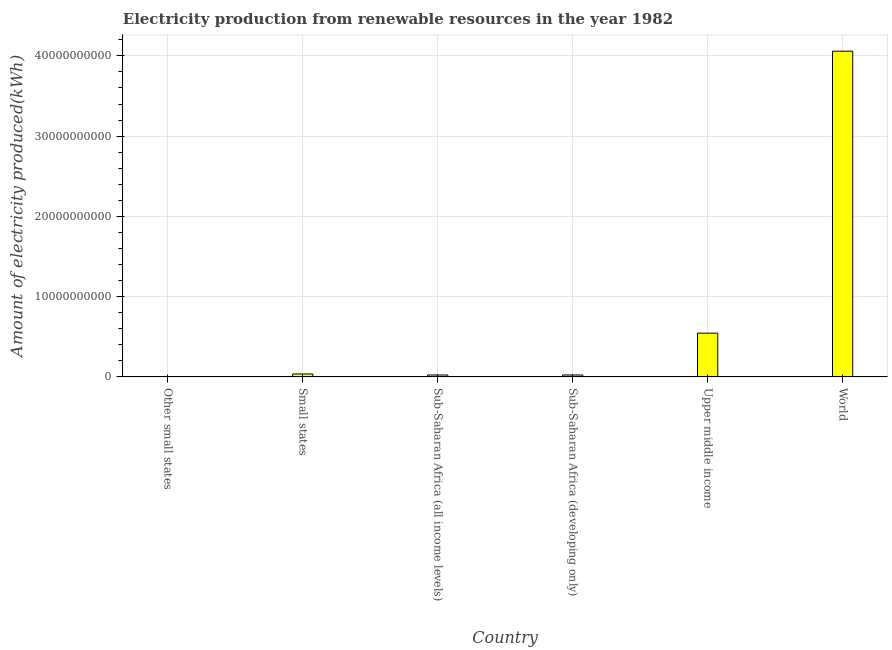Does the graph contain any zero values?
Provide a short and direct response. No. What is the title of the graph?
Offer a terse response. Electricity production from renewable resources in the year 1982. What is the label or title of the Y-axis?
Provide a short and direct response. Amount of electricity produced(kWh). What is the amount of electricity produced in Small states?
Offer a terse response. 3.60e+08. Across all countries, what is the maximum amount of electricity produced?
Provide a short and direct response. 4.06e+1. Across all countries, what is the minimum amount of electricity produced?
Offer a very short reply. 4.30e+07. In which country was the amount of electricity produced maximum?
Make the answer very short. World. In which country was the amount of electricity produced minimum?
Make the answer very short. Other small states. What is the sum of the amount of electricity produced?
Your answer should be compact. 4.69e+1. What is the difference between the amount of electricity produced in Sub-Saharan Africa (all income levels) and Upper middle income?
Ensure brevity in your answer.  -5.21e+09. What is the average amount of electricity produced per country?
Offer a very short reply. 7.82e+09. What is the median amount of electricity produced?
Give a very brief answer. 2.98e+08. What is the ratio of the amount of electricity produced in Small states to that in Sub-Saharan Africa (all income levels)?
Your answer should be very brief. 1.52. Is the amount of electricity produced in Upper middle income less than that in World?
Keep it short and to the point. Yes. What is the difference between the highest and the second highest amount of electricity produced?
Ensure brevity in your answer.  3.51e+1. What is the difference between the highest and the lowest amount of electricity produced?
Your answer should be very brief. 4.05e+1. In how many countries, is the amount of electricity produced greater than the average amount of electricity produced taken over all countries?
Provide a succinct answer. 1. Are all the bars in the graph horizontal?
Provide a short and direct response. No. How many countries are there in the graph?
Provide a short and direct response. 6. What is the difference between two consecutive major ticks on the Y-axis?
Offer a very short reply. 1.00e+1. Are the values on the major ticks of Y-axis written in scientific E-notation?
Provide a succinct answer. No. What is the Amount of electricity produced(kWh) of Other small states?
Make the answer very short. 4.30e+07. What is the Amount of electricity produced(kWh) in Small states?
Offer a terse response. 3.60e+08. What is the Amount of electricity produced(kWh) of Sub-Saharan Africa (all income levels)?
Offer a terse response. 2.37e+08. What is the Amount of electricity produced(kWh) of Sub-Saharan Africa (developing only)?
Your answer should be compact. 2.37e+08. What is the Amount of electricity produced(kWh) of Upper middle income?
Provide a succinct answer. 5.45e+09. What is the Amount of electricity produced(kWh) of World?
Offer a terse response. 4.06e+1. What is the difference between the Amount of electricity produced(kWh) in Other small states and Small states?
Provide a short and direct response. -3.17e+08. What is the difference between the Amount of electricity produced(kWh) in Other small states and Sub-Saharan Africa (all income levels)?
Offer a very short reply. -1.94e+08. What is the difference between the Amount of electricity produced(kWh) in Other small states and Sub-Saharan Africa (developing only)?
Provide a succinct answer. -1.94e+08. What is the difference between the Amount of electricity produced(kWh) in Other small states and Upper middle income?
Your answer should be compact. -5.41e+09. What is the difference between the Amount of electricity produced(kWh) in Other small states and World?
Ensure brevity in your answer.  -4.05e+1. What is the difference between the Amount of electricity produced(kWh) in Small states and Sub-Saharan Africa (all income levels)?
Your answer should be very brief. 1.23e+08. What is the difference between the Amount of electricity produced(kWh) in Small states and Sub-Saharan Africa (developing only)?
Your answer should be compact. 1.23e+08. What is the difference between the Amount of electricity produced(kWh) in Small states and Upper middle income?
Offer a terse response. -5.09e+09. What is the difference between the Amount of electricity produced(kWh) in Small states and World?
Offer a very short reply. -4.02e+1. What is the difference between the Amount of electricity produced(kWh) in Sub-Saharan Africa (all income levels) and Upper middle income?
Provide a succinct answer. -5.21e+09. What is the difference between the Amount of electricity produced(kWh) in Sub-Saharan Africa (all income levels) and World?
Provide a short and direct response. -4.04e+1. What is the difference between the Amount of electricity produced(kWh) in Sub-Saharan Africa (developing only) and Upper middle income?
Offer a very short reply. -5.21e+09. What is the difference between the Amount of electricity produced(kWh) in Sub-Saharan Africa (developing only) and World?
Provide a succinct answer. -4.04e+1. What is the difference between the Amount of electricity produced(kWh) in Upper middle income and World?
Ensure brevity in your answer.  -3.51e+1. What is the ratio of the Amount of electricity produced(kWh) in Other small states to that in Small states?
Ensure brevity in your answer.  0.12. What is the ratio of the Amount of electricity produced(kWh) in Other small states to that in Sub-Saharan Africa (all income levels)?
Provide a succinct answer. 0.18. What is the ratio of the Amount of electricity produced(kWh) in Other small states to that in Sub-Saharan Africa (developing only)?
Ensure brevity in your answer.  0.18. What is the ratio of the Amount of electricity produced(kWh) in Other small states to that in Upper middle income?
Your response must be concise. 0.01. What is the ratio of the Amount of electricity produced(kWh) in Small states to that in Sub-Saharan Africa (all income levels)?
Make the answer very short. 1.52. What is the ratio of the Amount of electricity produced(kWh) in Small states to that in Sub-Saharan Africa (developing only)?
Make the answer very short. 1.52. What is the ratio of the Amount of electricity produced(kWh) in Small states to that in Upper middle income?
Your answer should be very brief. 0.07. What is the ratio of the Amount of electricity produced(kWh) in Small states to that in World?
Your response must be concise. 0.01. What is the ratio of the Amount of electricity produced(kWh) in Sub-Saharan Africa (all income levels) to that in Upper middle income?
Offer a very short reply. 0.04. What is the ratio of the Amount of electricity produced(kWh) in Sub-Saharan Africa (all income levels) to that in World?
Give a very brief answer. 0.01. What is the ratio of the Amount of electricity produced(kWh) in Sub-Saharan Africa (developing only) to that in Upper middle income?
Offer a very short reply. 0.04. What is the ratio of the Amount of electricity produced(kWh) in Sub-Saharan Africa (developing only) to that in World?
Your response must be concise. 0.01. What is the ratio of the Amount of electricity produced(kWh) in Upper middle income to that in World?
Ensure brevity in your answer.  0.13. 